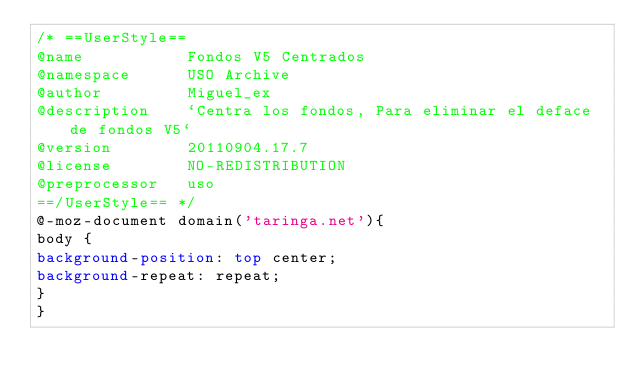Convert code to text. <code><loc_0><loc_0><loc_500><loc_500><_CSS_>/* ==UserStyle==
@name           Fondos V5 Centrados
@namespace      USO Archive
@author         Miguel_ex
@description    `Centra los fondos, Para eliminar el deface de fondos V5`
@version        20110904.17.7
@license        NO-REDISTRIBUTION
@preprocessor   uso
==/UserStyle== */
@-moz-document domain('taringa.net'){
body {
background-position: top center;
background-repeat: repeat;
}
}</code> 